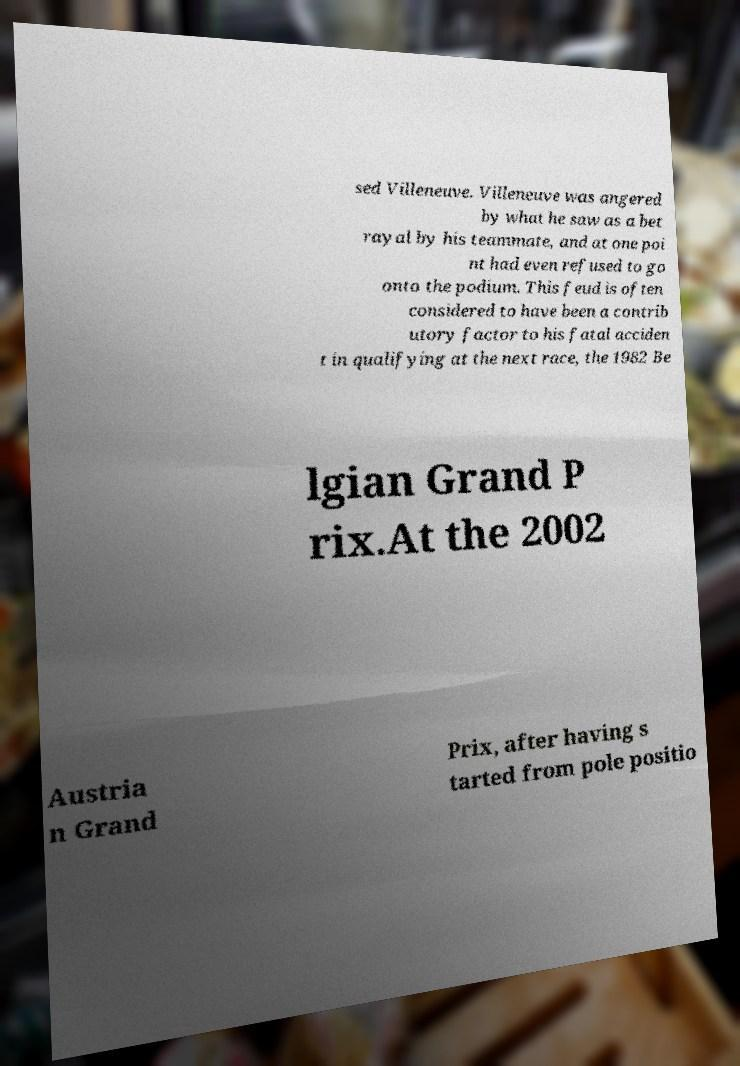Can you accurately transcribe the text from the provided image for me? sed Villeneuve. Villeneuve was angered by what he saw as a bet rayal by his teammate, and at one poi nt had even refused to go onto the podium. This feud is often considered to have been a contrib utory factor to his fatal acciden t in qualifying at the next race, the 1982 Be lgian Grand P rix.At the 2002 Austria n Grand Prix, after having s tarted from pole positio 